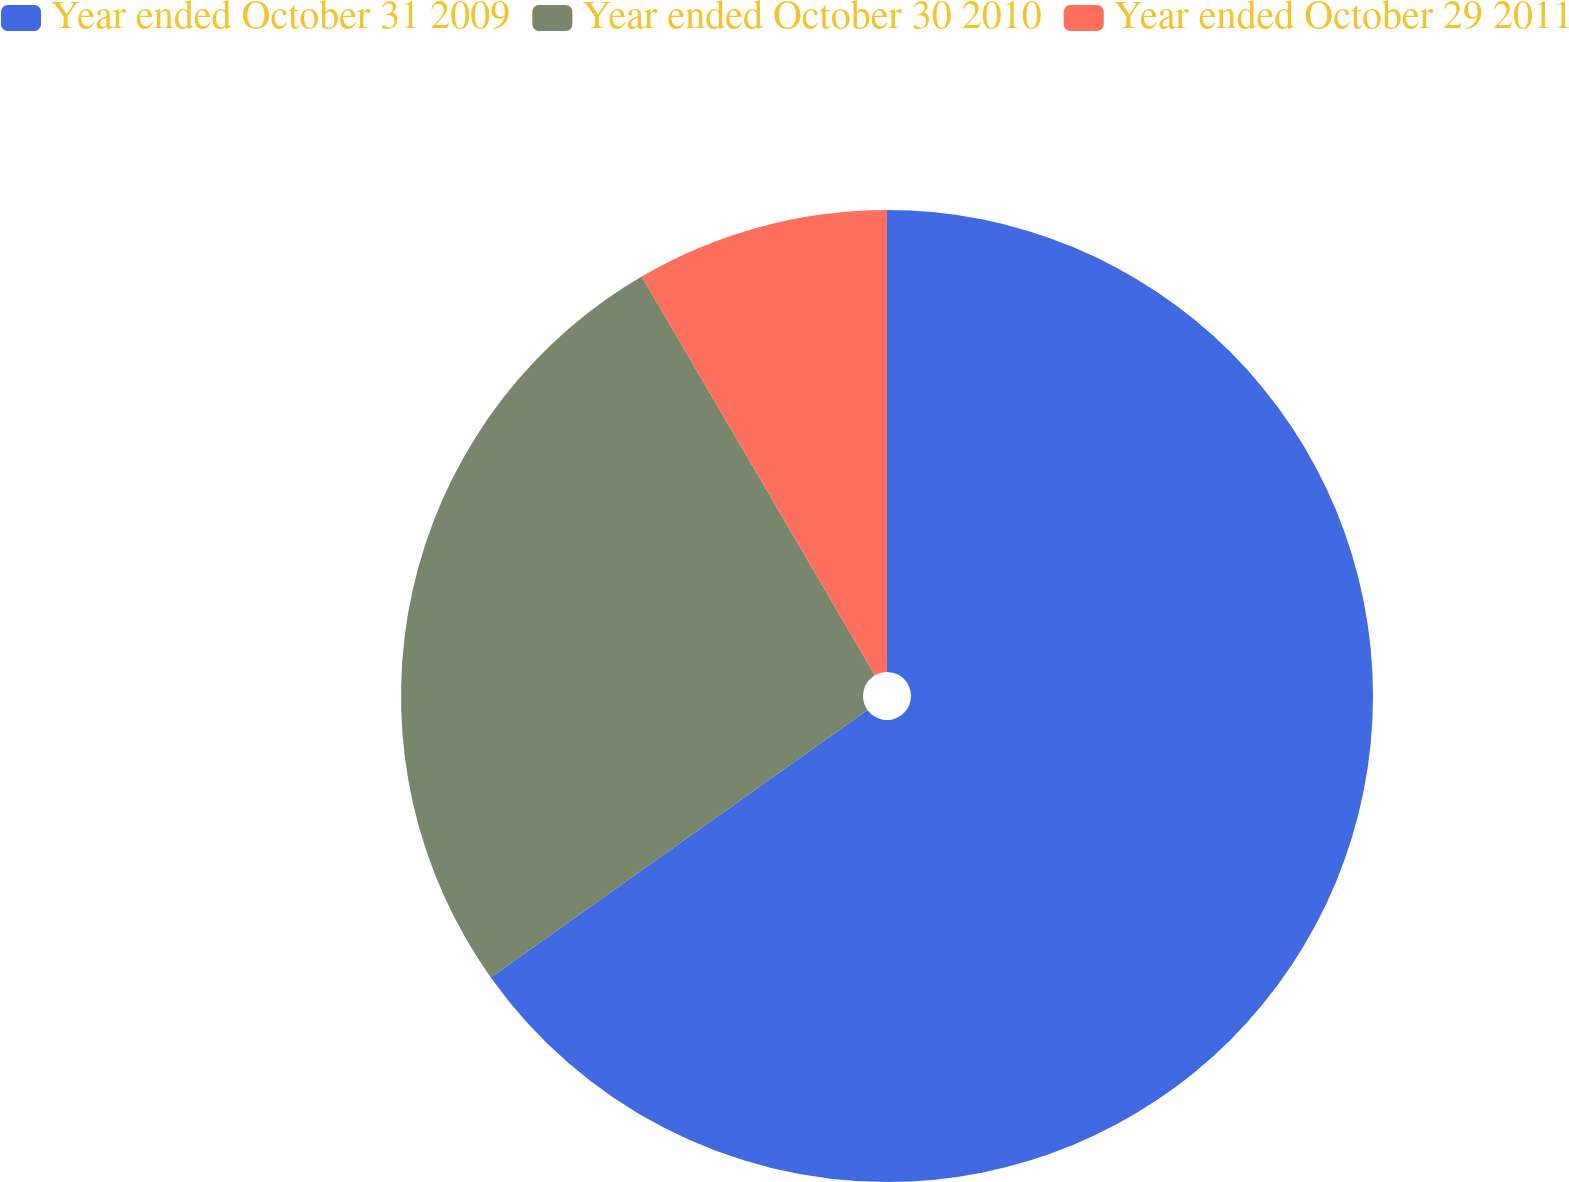Convert chart to OTSL. <chart><loc_0><loc_0><loc_500><loc_500><pie_chart><fcel>Year ended October 31 2009<fcel>Year ended October 30 2010<fcel>Year ended October 29 2011<nl><fcel>65.17%<fcel>26.41%<fcel>8.42%<nl></chart> 